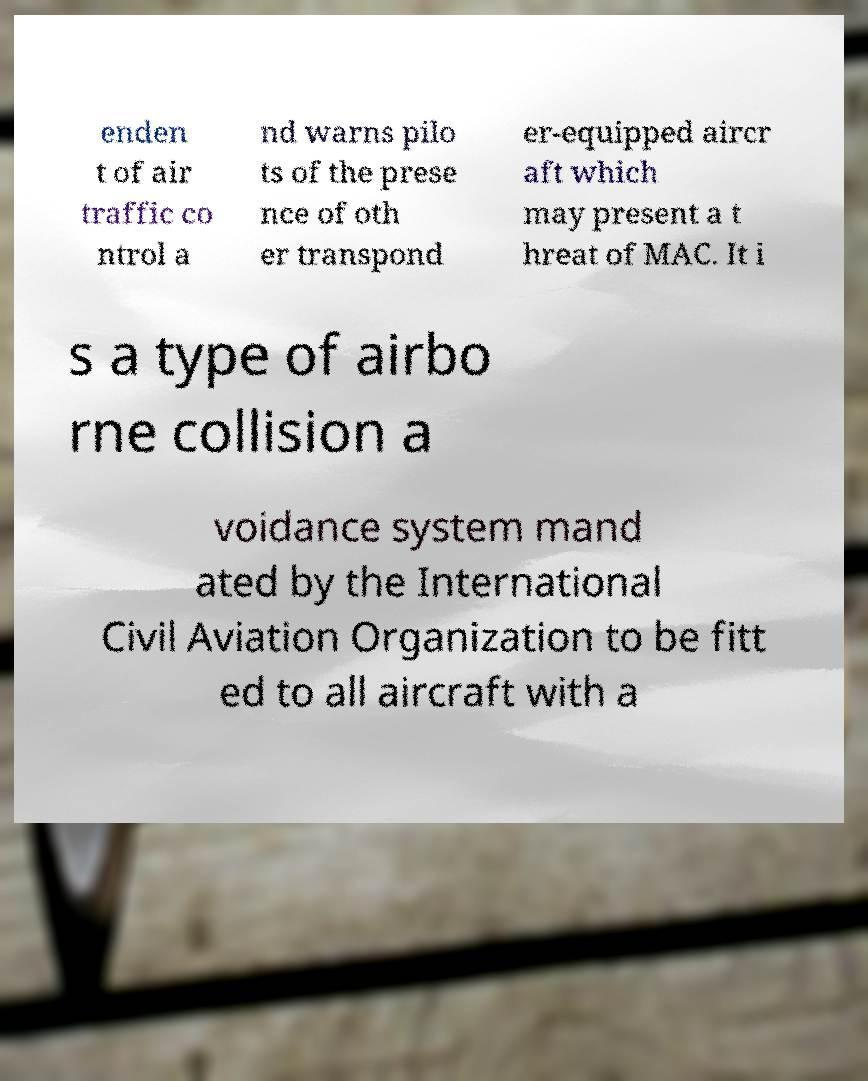Could you assist in decoding the text presented in this image and type it out clearly? enden t of air traffic co ntrol a nd warns pilo ts of the prese nce of oth er transpond er-equipped aircr aft which may present a t hreat of MAC. It i s a type of airbo rne collision a voidance system mand ated by the International Civil Aviation Organization to be fitt ed to all aircraft with a 